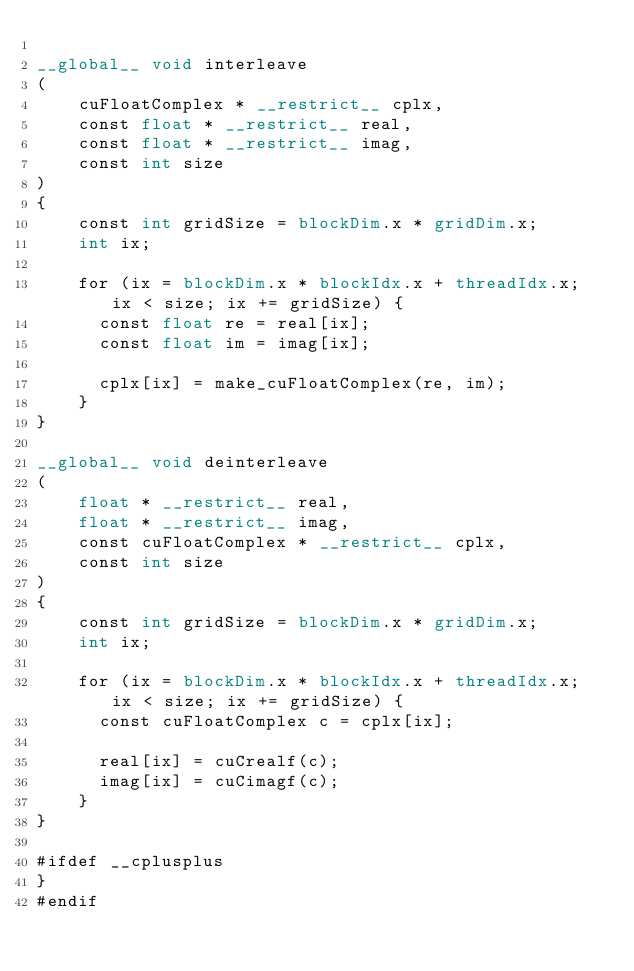Convert code to text. <code><loc_0><loc_0><loc_500><loc_500><_Cuda_>
__global__ void interleave
(
    cuFloatComplex * __restrict__ cplx,
    const float * __restrict__ real,
    const float * __restrict__ imag,
    const int size
)
{
    const int gridSize = blockDim.x * gridDim.x;
    int ix;

    for (ix = blockDim.x * blockIdx.x + threadIdx.x; ix < size; ix += gridSize) {
      const float re = real[ix];
      const float im = imag[ix];

      cplx[ix] = make_cuFloatComplex(re, im);
    }
}

__global__ void deinterleave
(
    float * __restrict__ real,
    float * __restrict__ imag,
    const cuFloatComplex * __restrict__ cplx,
    const int size
)
{
    const int gridSize = blockDim.x * gridDim.x;
    int ix;

    for (ix = blockDim.x * blockIdx.x + threadIdx.x; ix < size; ix += gridSize) {
      const cuFloatComplex c = cplx[ix];

      real[ix] = cuCrealf(c);
      imag[ix] = cuCimagf(c);
    }
}

#ifdef __cplusplus
}
#endif

</code> 